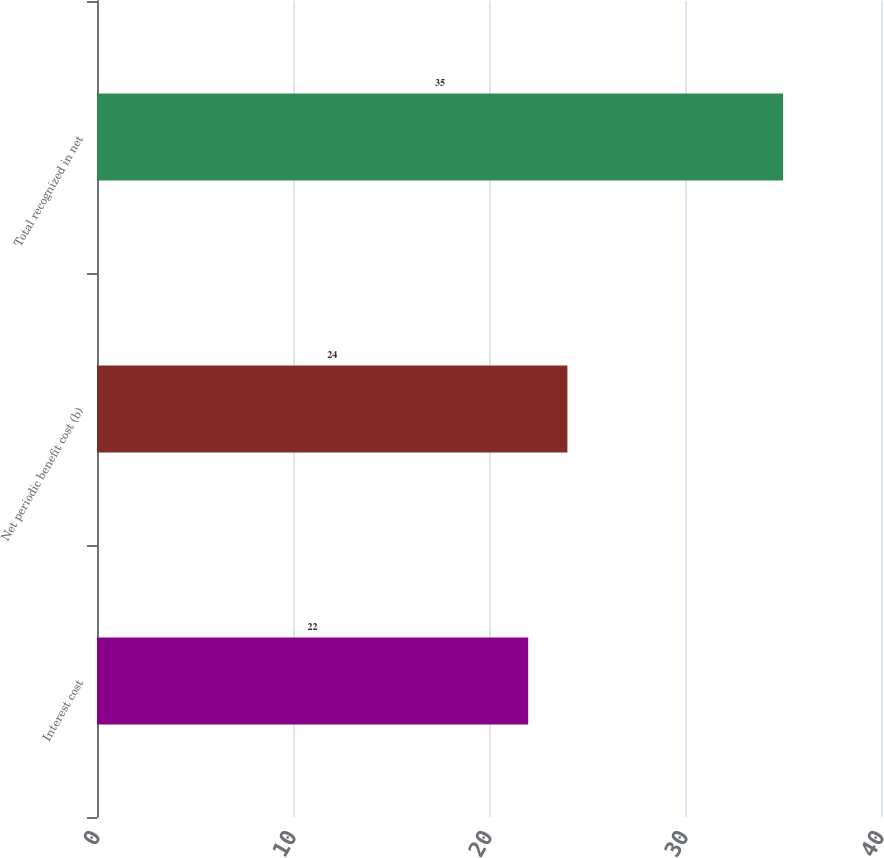Convert chart. <chart><loc_0><loc_0><loc_500><loc_500><bar_chart><fcel>Interest cost<fcel>Net periodic benefit cost (b)<fcel>Total recognized in net<nl><fcel>22<fcel>24<fcel>35<nl></chart> 